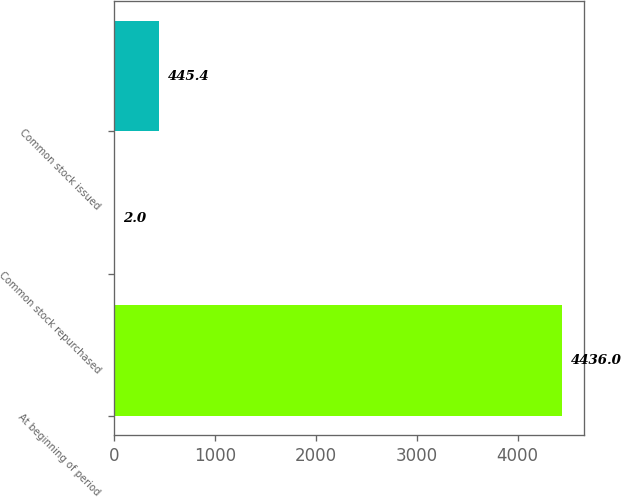Convert chart to OTSL. <chart><loc_0><loc_0><loc_500><loc_500><bar_chart><fcel>At beginning of period<fcel>Common stock repurchased<fcel>Common stock issued<nl><fcel>4436<fcel>2<fcel>445.4<nl></chart> 